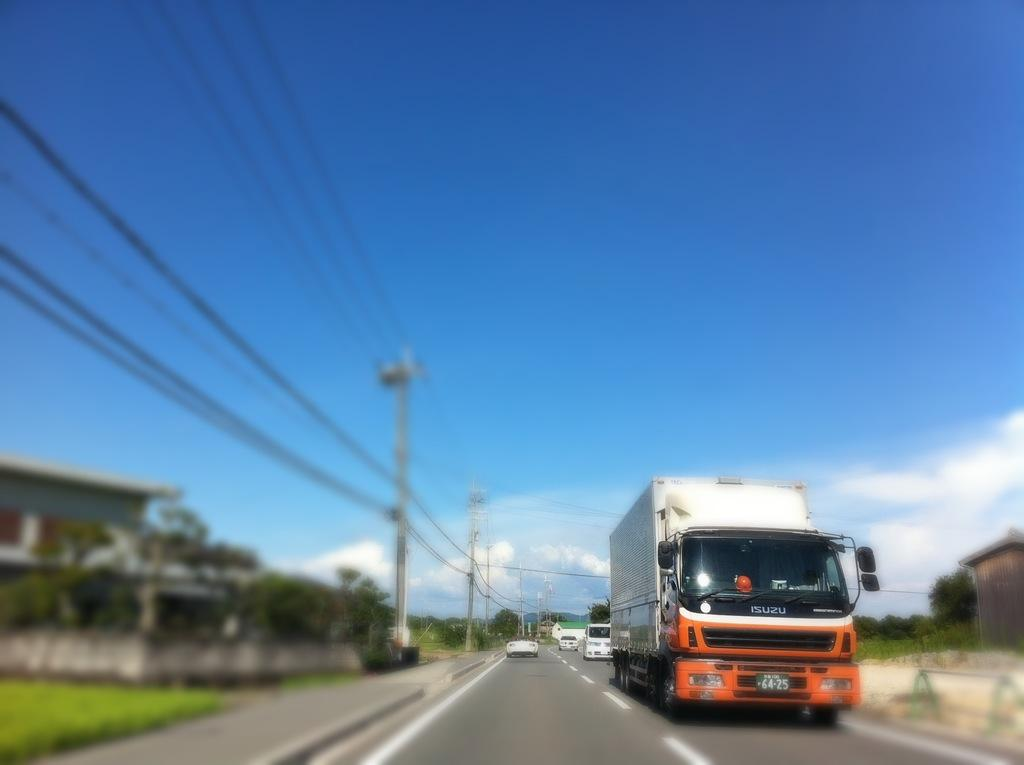What can be seen on the road in the image? There is a group of vehicles on the road in the image. What type of structures can be seen in the image? There are buildings visible in the image. What are the poles with wires used for? The poles with wires are likely used for electrical or communication purposes. What type of vegetation is visible in the image? Grass is visible in the image. What material are the poles made of? The poles are made of metal. What is the condition of the sky in the image? The sky is visible and appears cloudy in the image. What type of ship can be seen sailing in the image? There is no ship present in the image; it features a group of vehicles on the road, buildings, poles with wires, grass, and a cloudy sky. What type of shade is provided by the trees in the image? There are no trees present in the image, so no shade is provided. 